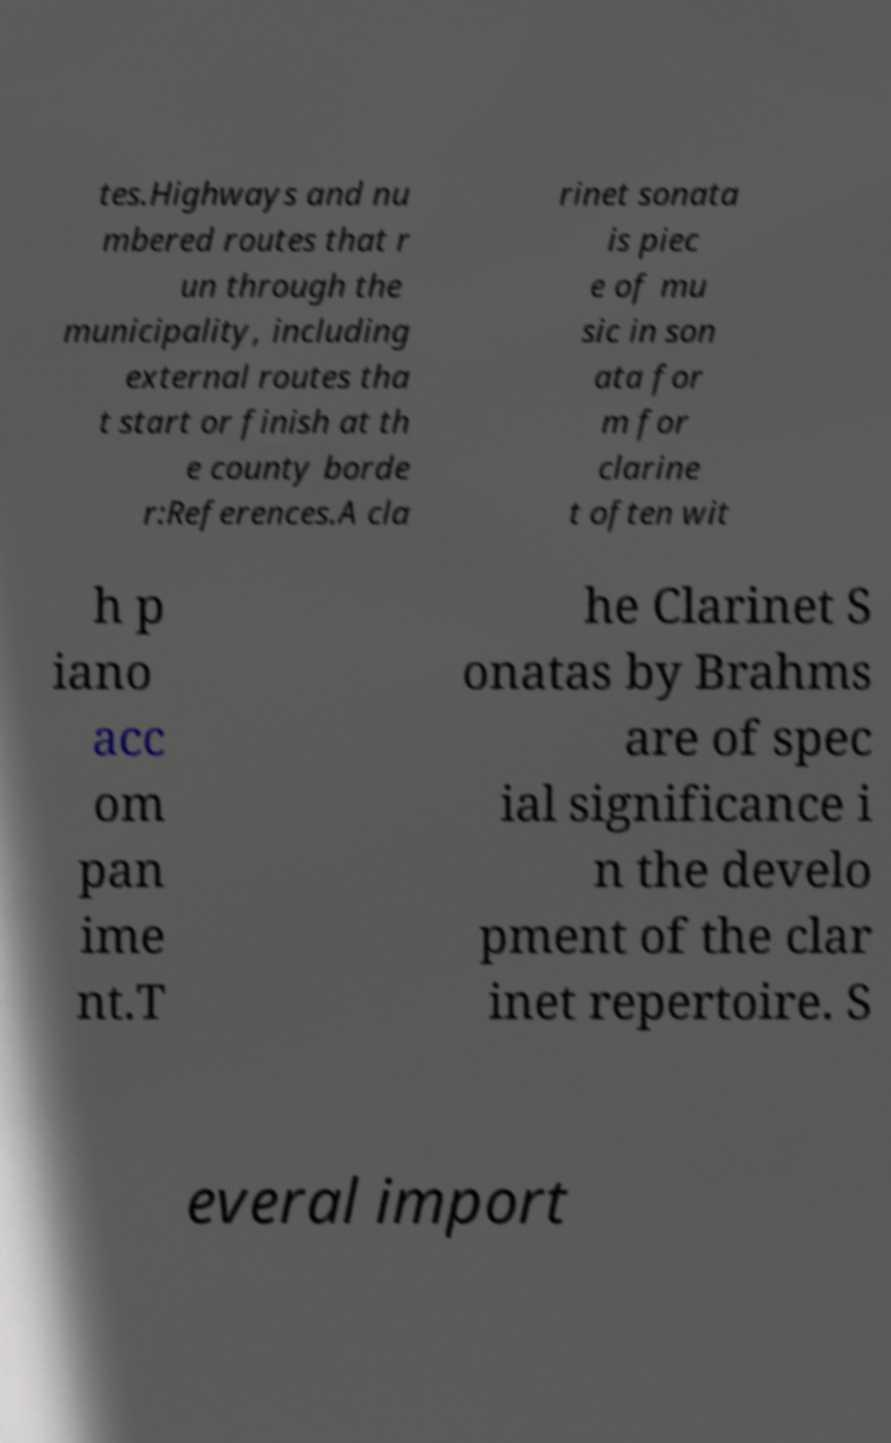There's text embedded in this image that I need extracted. Can you transcribe it verbatim? tes.Highways and nu mbered routes that r un through the municipality, including external routes tha t start or finish at th e county borde r:References.A cla rinet sonata is piec e of mu sic in son ata for m for clarine t often wit h p iano acc om pan ime nt.T he Clarinet S onatas by Brahms are of spec ial significance i n the develo pment of the clar inet repertoire. S everal import 